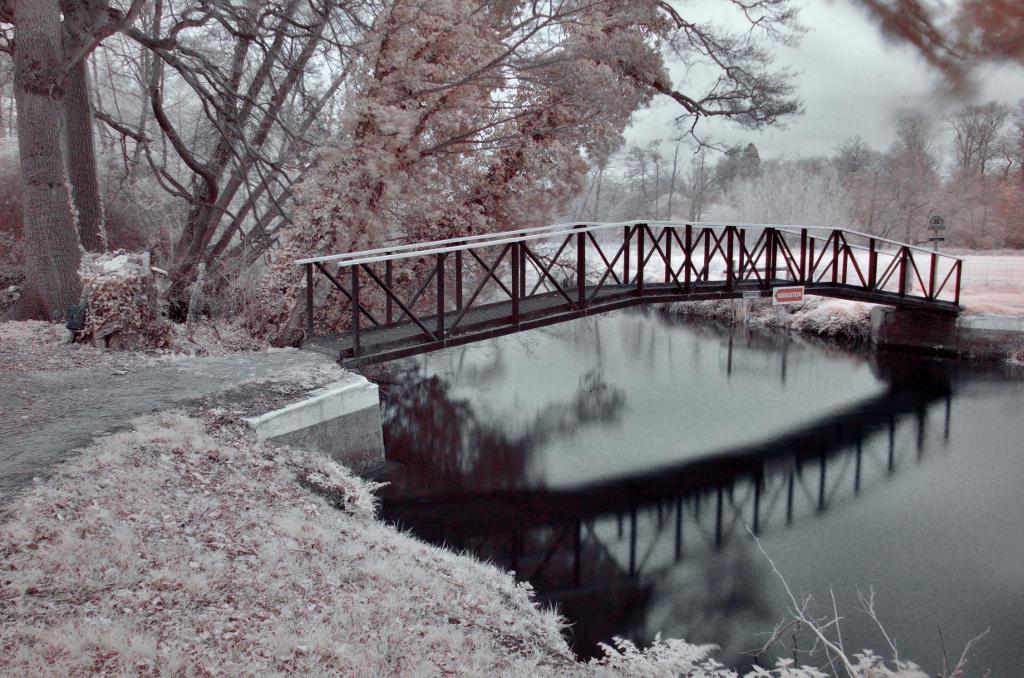In one or two sentences, can you explain what this image depicts? In the picture we can see a canal around it we can see a path and on the canal we can see a bridge path with railing and beside we can see some trees and in the background also we can see trees and sky. 